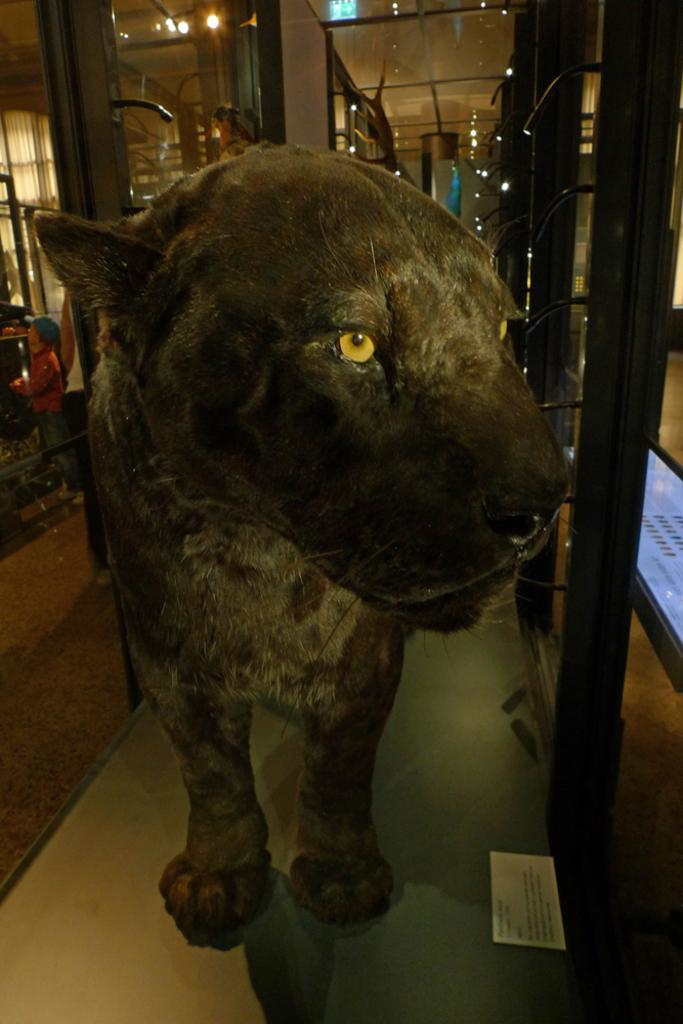What is the main subject of the image? There is a statue of an animal in the image. Where is the statue located? The statue is on a surface. What else can be seen beside the statue? There is a paper beside the statue. What type of structures are present in the image? There are metal poles in the image. How many people are in the image? Two persons are standing in the image. What can be seen in terms of illumination in the image? There are lights visible in the image. Reasoning: Let'ing: Let's think step by step in order to produce the conversation. We start by identifying the main subject of the image, which is the statue of an animal. Then, we describe the location of the statue and any other objects or items that are visible in the image. We also mention the presence of people and lights to provide a more complete description of the scene. Absurd Question/Answer: What type of tent is visible in the image? There is no tent present in the image. How many eggs are being held by the persons in the image? There are no eggs visible in the image. 